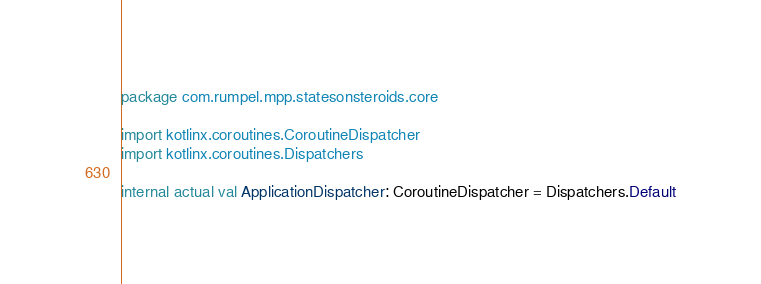Convert code to text. <code><loc_0><loc_0><loc_500><loc_500><_Kotlin_>package com.rumpel.mpp.statesonsteroids.core

import kotlinx.coroutines.CoroutineDispatcher
import kotlinx.coroutines.Dispatchers

internal actual val ApplicationDispatcher: CoroutineDispatcher = Dispatchers.Default
</code> 